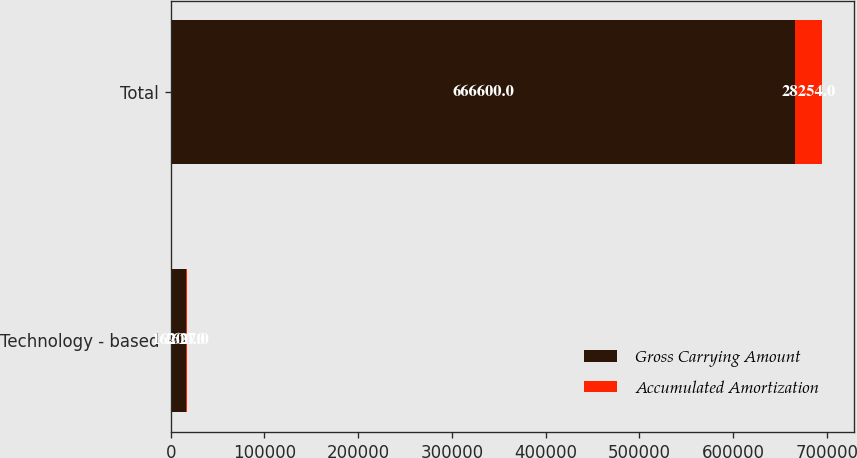<chart> <loc_0><loc_0><loc_500><loc_500><stacked_bar_chart><ecel><fcel>Technology - based<fcel>Total<nl><fcel>Gross Carrying Amount<fcel>16200<fcel>666600<nl><fcel>Accumulated Amortization<fcel>1627<fcel>28254<nl></chart> 